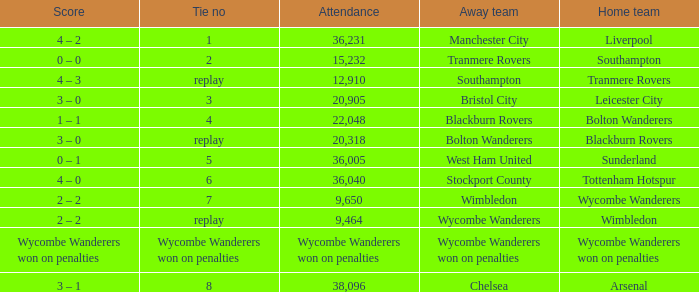What was the attendance for the game where the away team was Stockport County? 36040.0. 